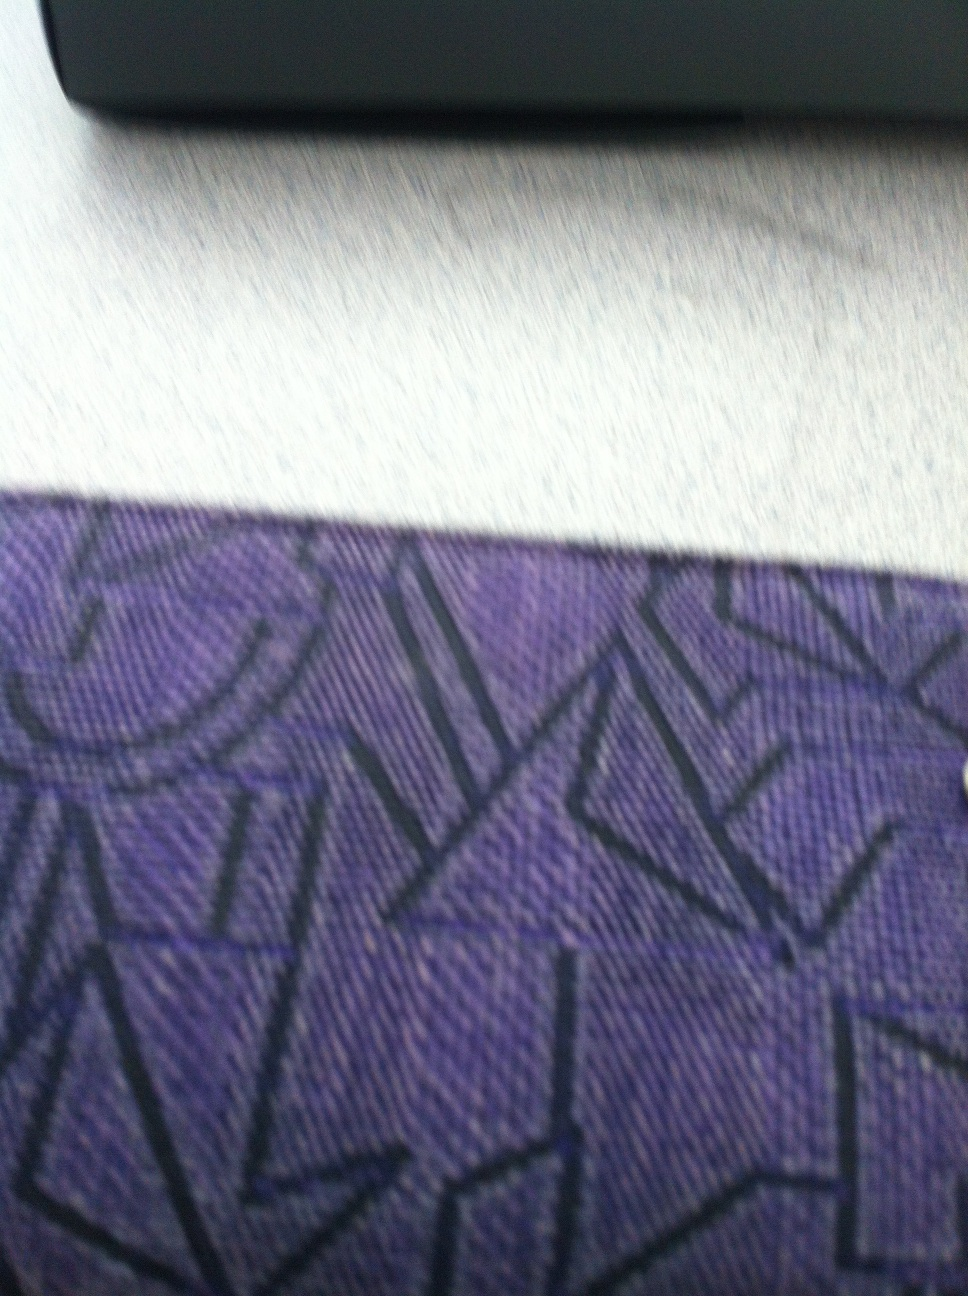What could have inspired the design on my wallet? The design on your wallet could be inspired by modern abstract art, characterized by geometric shapes and bold lines. Such designs often draw inspiration from various art movements including cubism and futurism. That's quite interesting! What else can you say about the use of colors? The deep purple color of your wallet is both elegant and royal, often associated with luxury and creativity. Combined with the black geometric patterns, it provides a striking yet harmonious contrast. This combination not only enhances the aesthetic appeal but also makes the design more visually engaging. 